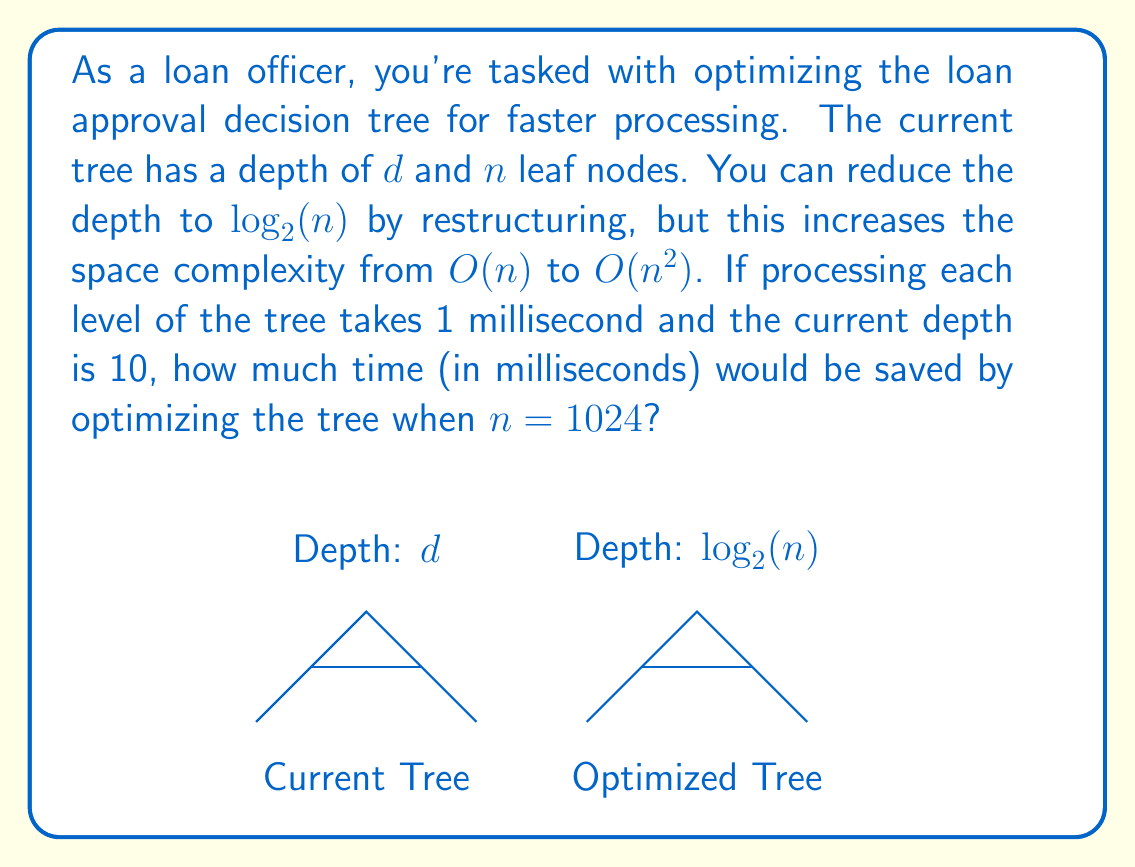What is the answer to this math problem? Let's approach this step-by-step:

1) First, we need to calculate the depth of the optimized tree:
   $\log_2(n) = \log_2(1024) = 10$

2) We're told that the current depth $d$ is 10. This means both trees have the same depth in this case.

3) However, the question asks how much time would be saved. To calculate this, we need to compare the processing times:

   Current tree processing time: $10 \text{ ms}$ (1 ms per level, 10 levels)
   Optimized tree processing time: $10 \text{ ms}$ (1 ms per level, 10 levels)

4) Time saved = Current processing time - Optimized processing time
               $= 10 \text{ ms} - 10 \text{ ms} = 0 \text{ ms}$

5) It's worth noting that while no time is saved in this specific case, the optimized tree structure allows for faster processing when $n > 1024$, as its depth grows logarithmically with $n$ while the original tree's depth might grow linearly.

6) The trade-off is the increased space complexity from $O(n)$ to $O(n^2)$, which means significantly more memory usage for larger values of $n$.
Answer: $0 \text{ ms}$ 